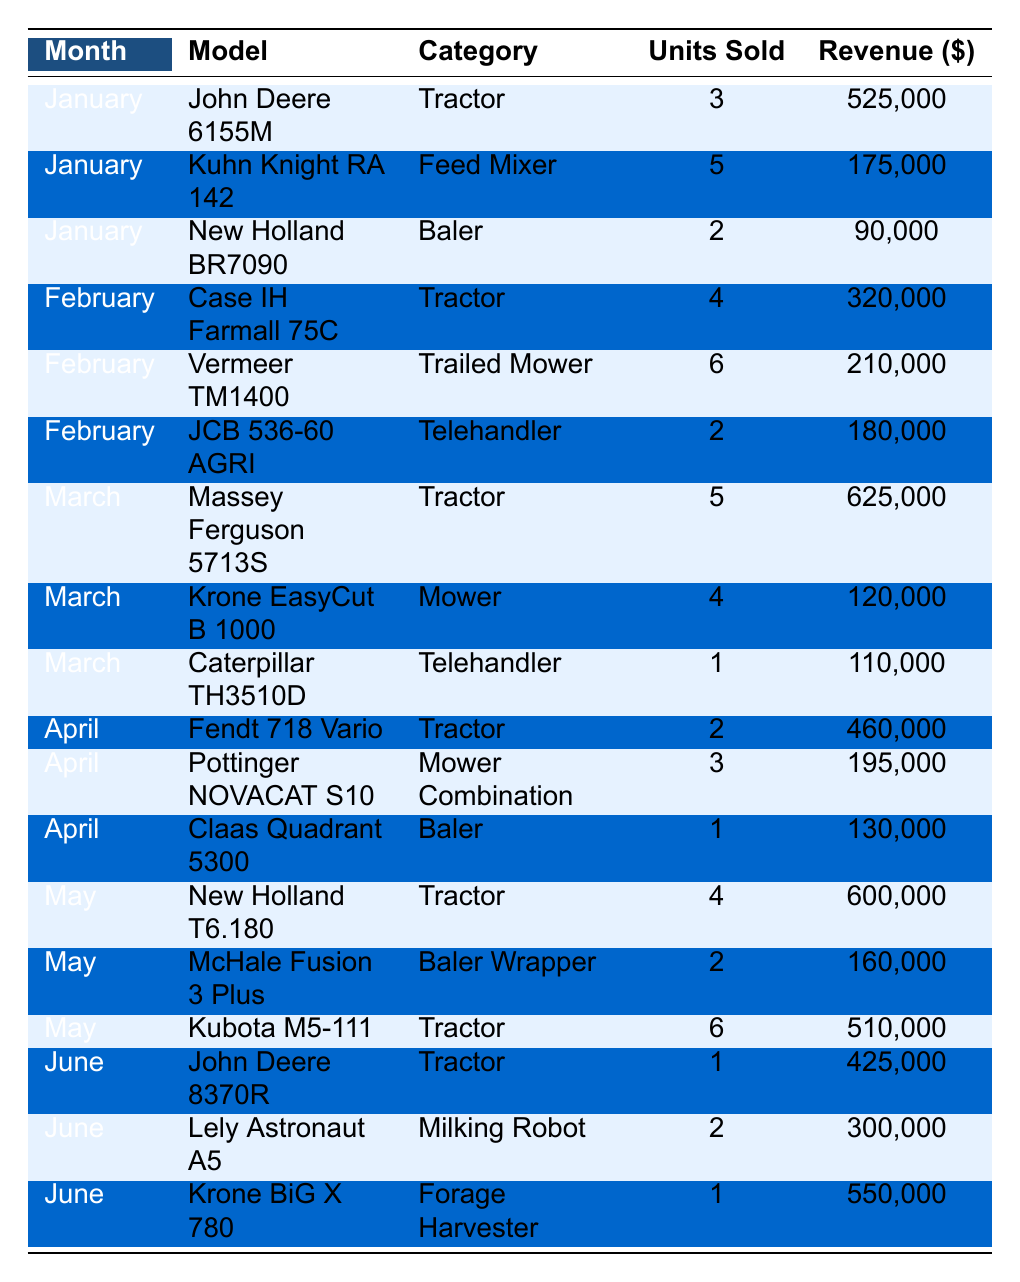What was the total revenue generated from selling tractors in May? In May, the sales of tractors were as follows: New Holland T6.180 (4 units sold, $600,000), Kubota M5-111 (6 units sold, $510,000). Summing these revenues gives $600,000 + $510,000 = $1,110,000.
Answer: $1,110,000 Which model had the highest revenue in March? In March, the models and their revenues were: Massey Ferguson 5713S ($625,000), Krone EasyCut B 1000 ($120,000), Caterpillar TH3510D ($110,000). The highest revenue is from Massey Ferguson 5713S with $625,000.
Answer: Massey Ferguson 5713S How many units of the Lely Astronaut A5 were sold in June? Referring to June's data, Lely Astronaut A5 sold 2 units.
Answer: 2 units What is the average units sold for all Feed Mixer models listed? Only one Feed Mixer model is listed (Kuhn Knight RA 142), with 5 units sold. Therefore, the average is simply 5 / 1 = 5.
Answer: 5 Did any models sell fewer than three units in April? In April, the units sold were: Fendt 718 Vario (2 units), Pottinger NOVACAT S10 (3 units), and Claas Quadrant 5300 (1 unit). The Fendt 718 Vario and Claas Quadrant 5300 both sold fewer than three units (2 and 1 respectively).
Answer: Yes What was the total number of units sold across all categories from January to June? Adding the units sold each month: January (10), February (12), March (10), April (6), May (12), June (4) gives us 10 + 12 + 10 + 6 + 12 + 4 = 54 units sold in total.
Answer: 54 units Which category generated the most revenue overall? Summing revenues by category: Tractors ($2,520,000), Feed Mixers ($175,000), Balers ($370,000), Trailed Mowers ($210,000), Telehandlers ($290,000), Mower Combinations ($195,000), Baler Wrappers ($160,000), Milking Robots ($300,000), Forage Harvesters ($550,000). The highest total revenue comes from the Tractor category at $2,520,000.
Answer: Tractors Which month saw the highest total sales revenue? Monthly revenues were: January ($790,000), February ($710,000), March ($855,000), April ($785,000), May ($1,270,000), June ($1,275,000). The highest total revenue was in June with $1,275,000.
Answer: June How many different models were sold across the months listed? The following unique models were sold: 12 distinct models were identified in the data set.
Answer: 12 models What percentage of the total units sold in February were Trailed Mowers? In February, 12 units were sold in total (4 tractors, 6 Mowers, 2 Telehandlers), and 6 units were Trailed Mowers. The percentage is (6 / 12) * 100% = 50%.
Answer: 50% 